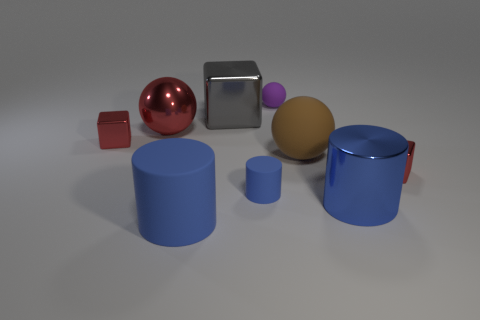Can you tell me the colors of the objects from the left? From the left, the first object is a small red cube, followed by a reflective red sphere. Next is a metallic cube that appears silver, then a smaller purple sphere atop a beige cube. Finally, there are two large blue cylinders of different heights, the smaller one of which has the same color and material as a tiny blue cylinder. 